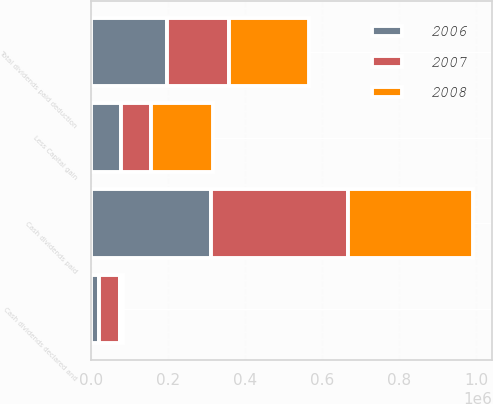<chart> <loc_0><loc_0><loc_500><loc_500><stacked_bar_chart><ecel><fcel>Cash dividends paid<fcel>Cash dividends declared and<fcel>Less Capital gain<fcel>Total dividends paid deduction<nl><fcel>2007<fcel>355782<fcel>52471<fcel>76709<fcel>161666<nl><fcel>2008<fcel>324085<fcel>7795<fcel>160797<fcel>207964<nl><fcel>2006<fcel>311615<fcel>21782<fcel>78246<fcel>196569<nl></chart> 